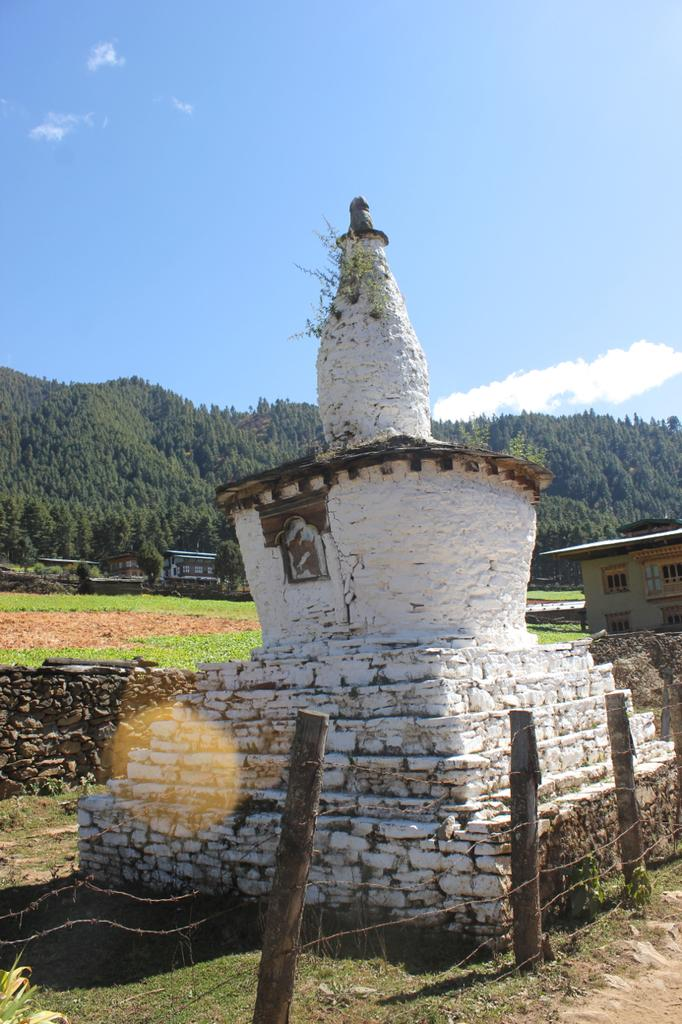What type of objects can be seen in the image? There are wooden poles and wires in the image. What can be seen in the background of the image? In the background, there is a white color thing, buildings, grass, trees, clouds, and the sky. Can you describe the natural elements visible in the background? The natural elements in the background include grass, trees, clouds, and the sky. How many apples are hanging from the wires in the image? There are no apples present in the image; it features wooden poles and wires. What story is being told by the wooden poles and wires in the image? The wooden poles and wires in the image are not telling a story; they are simply objects in the scene. 